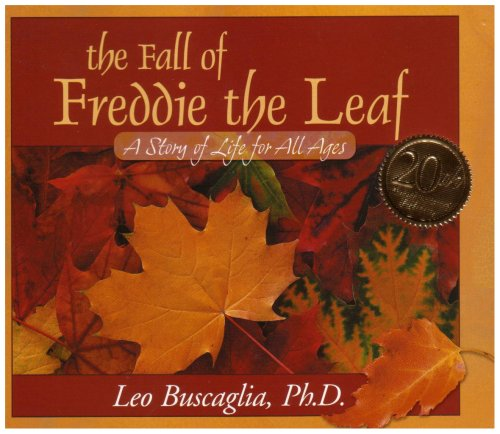Who is the author of this book? The author of the book displayed in the image is Leo Buscaglia, Ph.D., who is renowned for his inspirational work and motivational writings. 